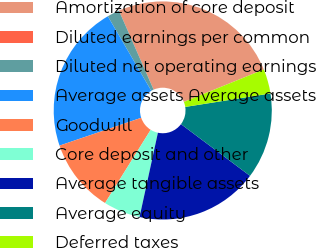<chart> <loc_0><loc_0><loc_500><loc_500><pie_chart><fcel>Amortization of core deposit<fcel>Diluted earnings per common<fcel>Diluted net operating earnings<fcel>Average assets Average assets<fcel>Goodwill<fcel>Core deposit and other<fcel>Average tangible assets<fcel>Average equity<fcel>Deferred taxes<nl><fcel>25.45%<fcel>0.0%<fcel>1.82%<fcel>21.82%<fcel>10.91%<fcel>5.46%<fcel>18.18%<fcel>12.73%<fcel>3.64%<nl></chart> 